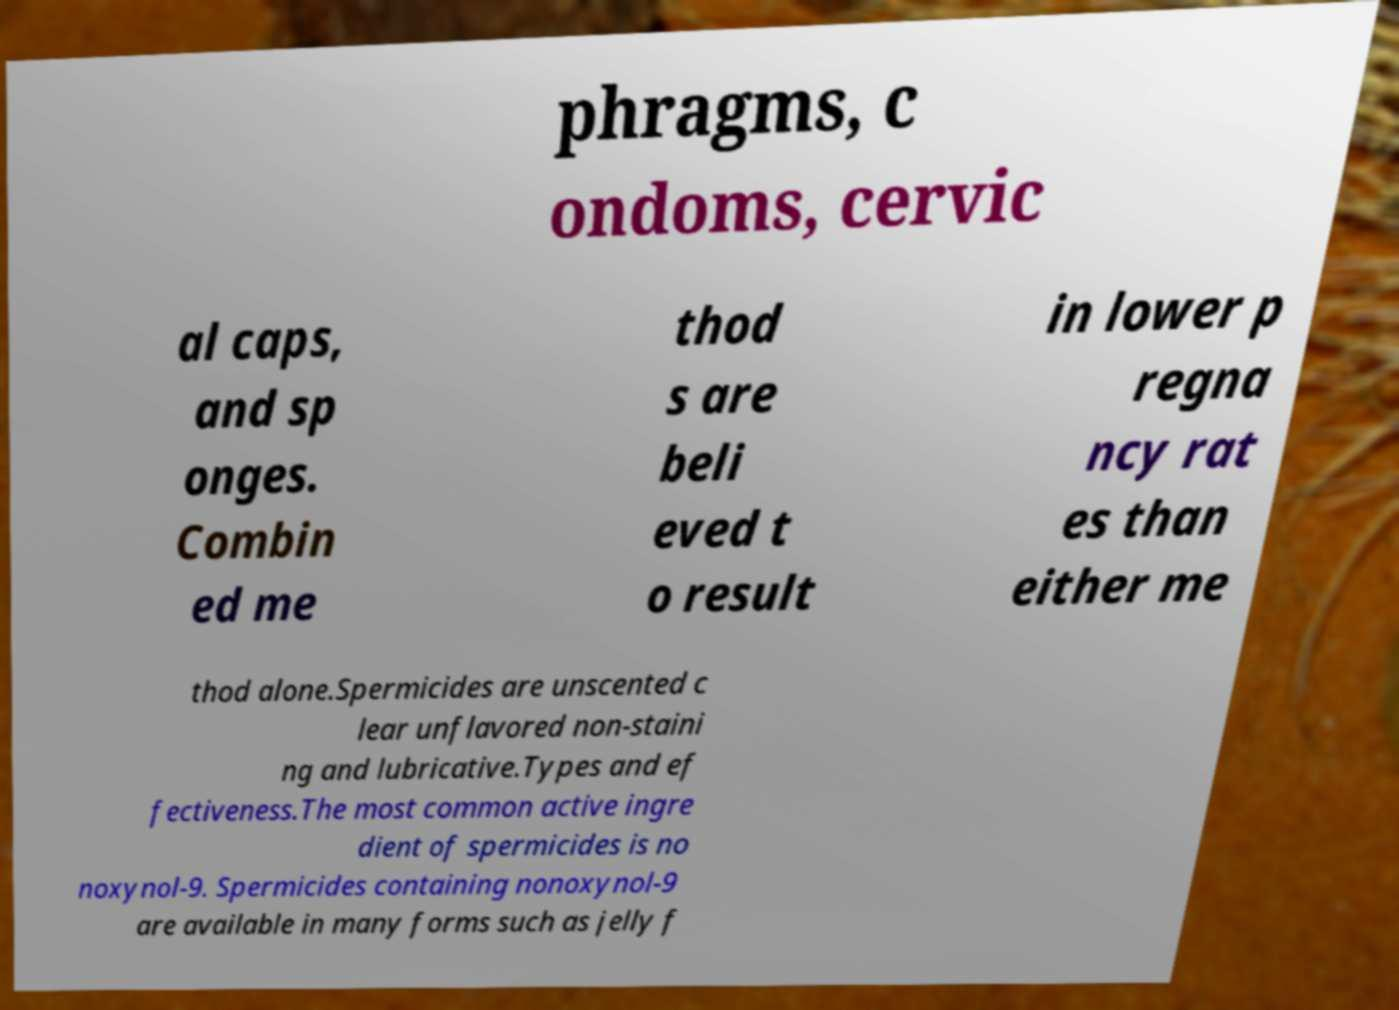Please identify and transcribe the text found in this image. phragms, c ondoms, cervic al caps, and sp onges. Combin ed me thod s are beli eved t o result in lower p regna ncy rat es than either me thod alone.Spermicides are unscented c lear unflavored non-staini ng and lubricative.Types and ef fectiveness.The most common active ingre dient of spermicides is no noxynol-9. Spermicides containing nonoxynol-9 are available in many forms such as jelly f 